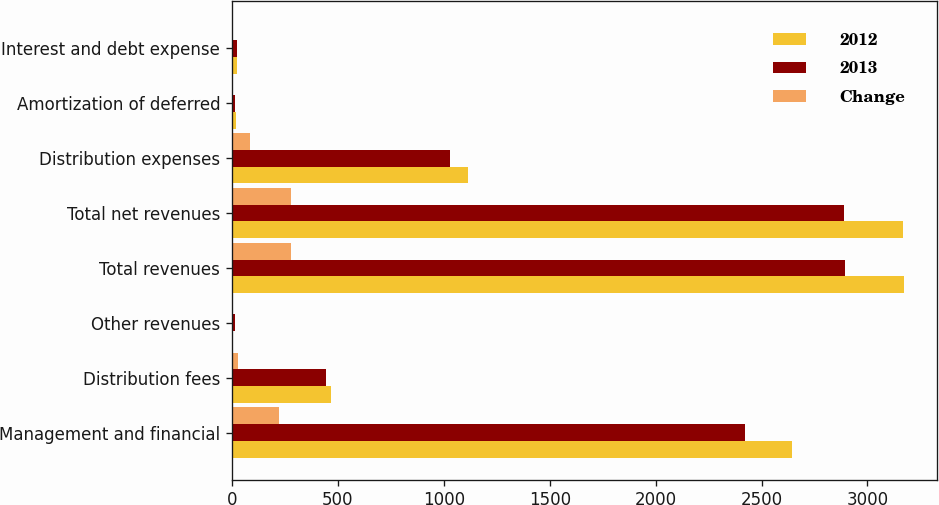Convert chart. <chart><loc_0><loc_0><loc_500><loc_500><stacked_bar_chart><ecel><fcel>Management and financial<fcel>Distribution fees<fcel>Other revenues<fcel>Total revenues<fcel>Total net revenues<fcel>Distribution expenses<fcel>Amortization of deferred<fcel>Interest and debt expense<nl><fcel>2012<fcel>2643<fcel>469<fcel>5<fcel>3171<fcel>3169<fcel>1112<fcel>17<fcel>24<nl><fcel>2013<fcel>2420<fcel>442<fcel>12<fcel>2893<fcel>2891<fcel>1029<fcel>16<fcel>22<nl><fcel>Change<fcel>223<fcel>27<fcel>7<fcel>278<fcel>278<fcel>83<fcel>1<fcel>2<nl></chart> 